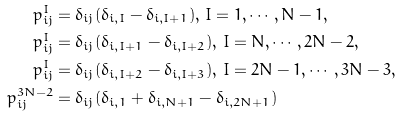Convert formula to latex. <formula><loc_0><loc_0><loc_500><loc_500>p ^ { I } _ { i j } & = \delta _ { i j } ( \delta _ { i , I } - \delta _ { i , I + 1 } ) , \, I = 1 , \cdots , N - 1 , \\ p ^ { I } _ { i j } & = \delta _ { i j } ( \delta _ { i , I + 1 } - \delta _ { i , I + 2 } ) , \, I = N , \cdots , 2 N - 2 , \\ p ^ { I } _ { i j } & = \delta _ { i j } ( \delta _ { i , I + 2 } - \delta _ { i , I + 3 } ) , \, I = 2 N - 1 , \cdots , 3 N - 3 , \\ p ^ { 3 N - 2 } _ { i j } & = \delta _ { i j } ( \delta _ { i , 1 } + \delta _ { i , N + 1 } - \delta _ { i , 2 N + 1 } )</formula> 